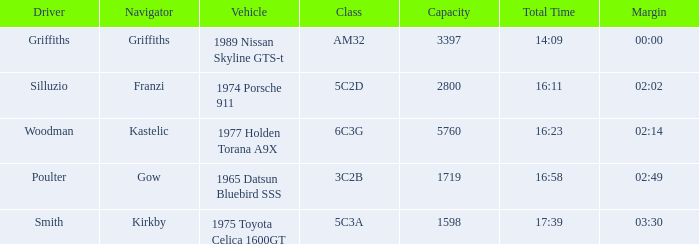What's the lowest capacity when the margin is 03:30? 1598.0. 